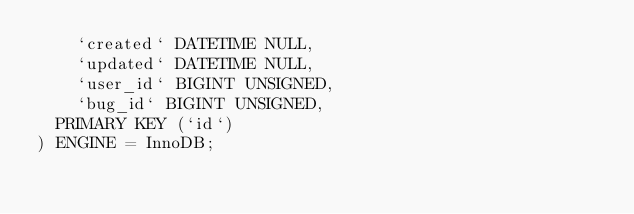Convert code to text. <code><loc_0><loc_0><loc_500><loc_500><_SQL_>    `created` DATETIME NULL,
    `updated` DATETIME NULL,
    `user_id` BIGINT UNSIGNED,
    `bug_id` BIGINT UNSIGNED,
	PRIMARY KEY (`id`)
) ENGINE = InnoDB;</code> 